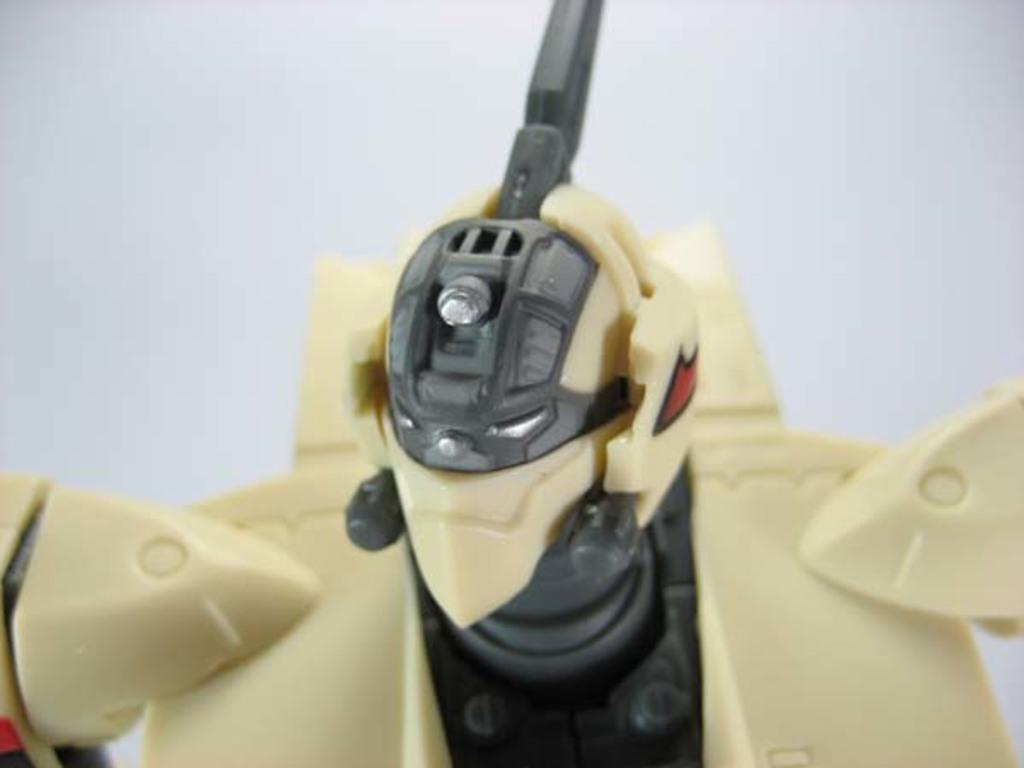What object in the image is designed for play or entertainment? There is a toy in the image. What type of government is depicted in the image? There is no government depicted in the image; it features a toy. How many coaches are present in the image? There are no coaches present in the image; it features a toy. 